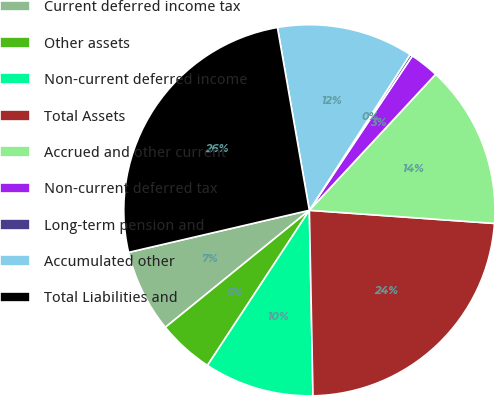<chart> <loc_0><loc_0><loc_500><loc_500><pie_chart><fcel>Current deferred income tax<fcel>Other assets<fcel>Non-current deferred income<fcel>Total Assets<fcel>Accrued and other current<fcel>Non-current deferred tax<fcel>Long-term pension and<fcel>Accumulated other<fcel>Total Liabilities and<nl><fcel>7.22%<fcel>4.89%<fcel>9.56%<fcel>23.56%<fcel>14.22%<fcel>2.55%<fcel>0.22%<fcel>11.89%<fcel>25.89%<nl></chart> 